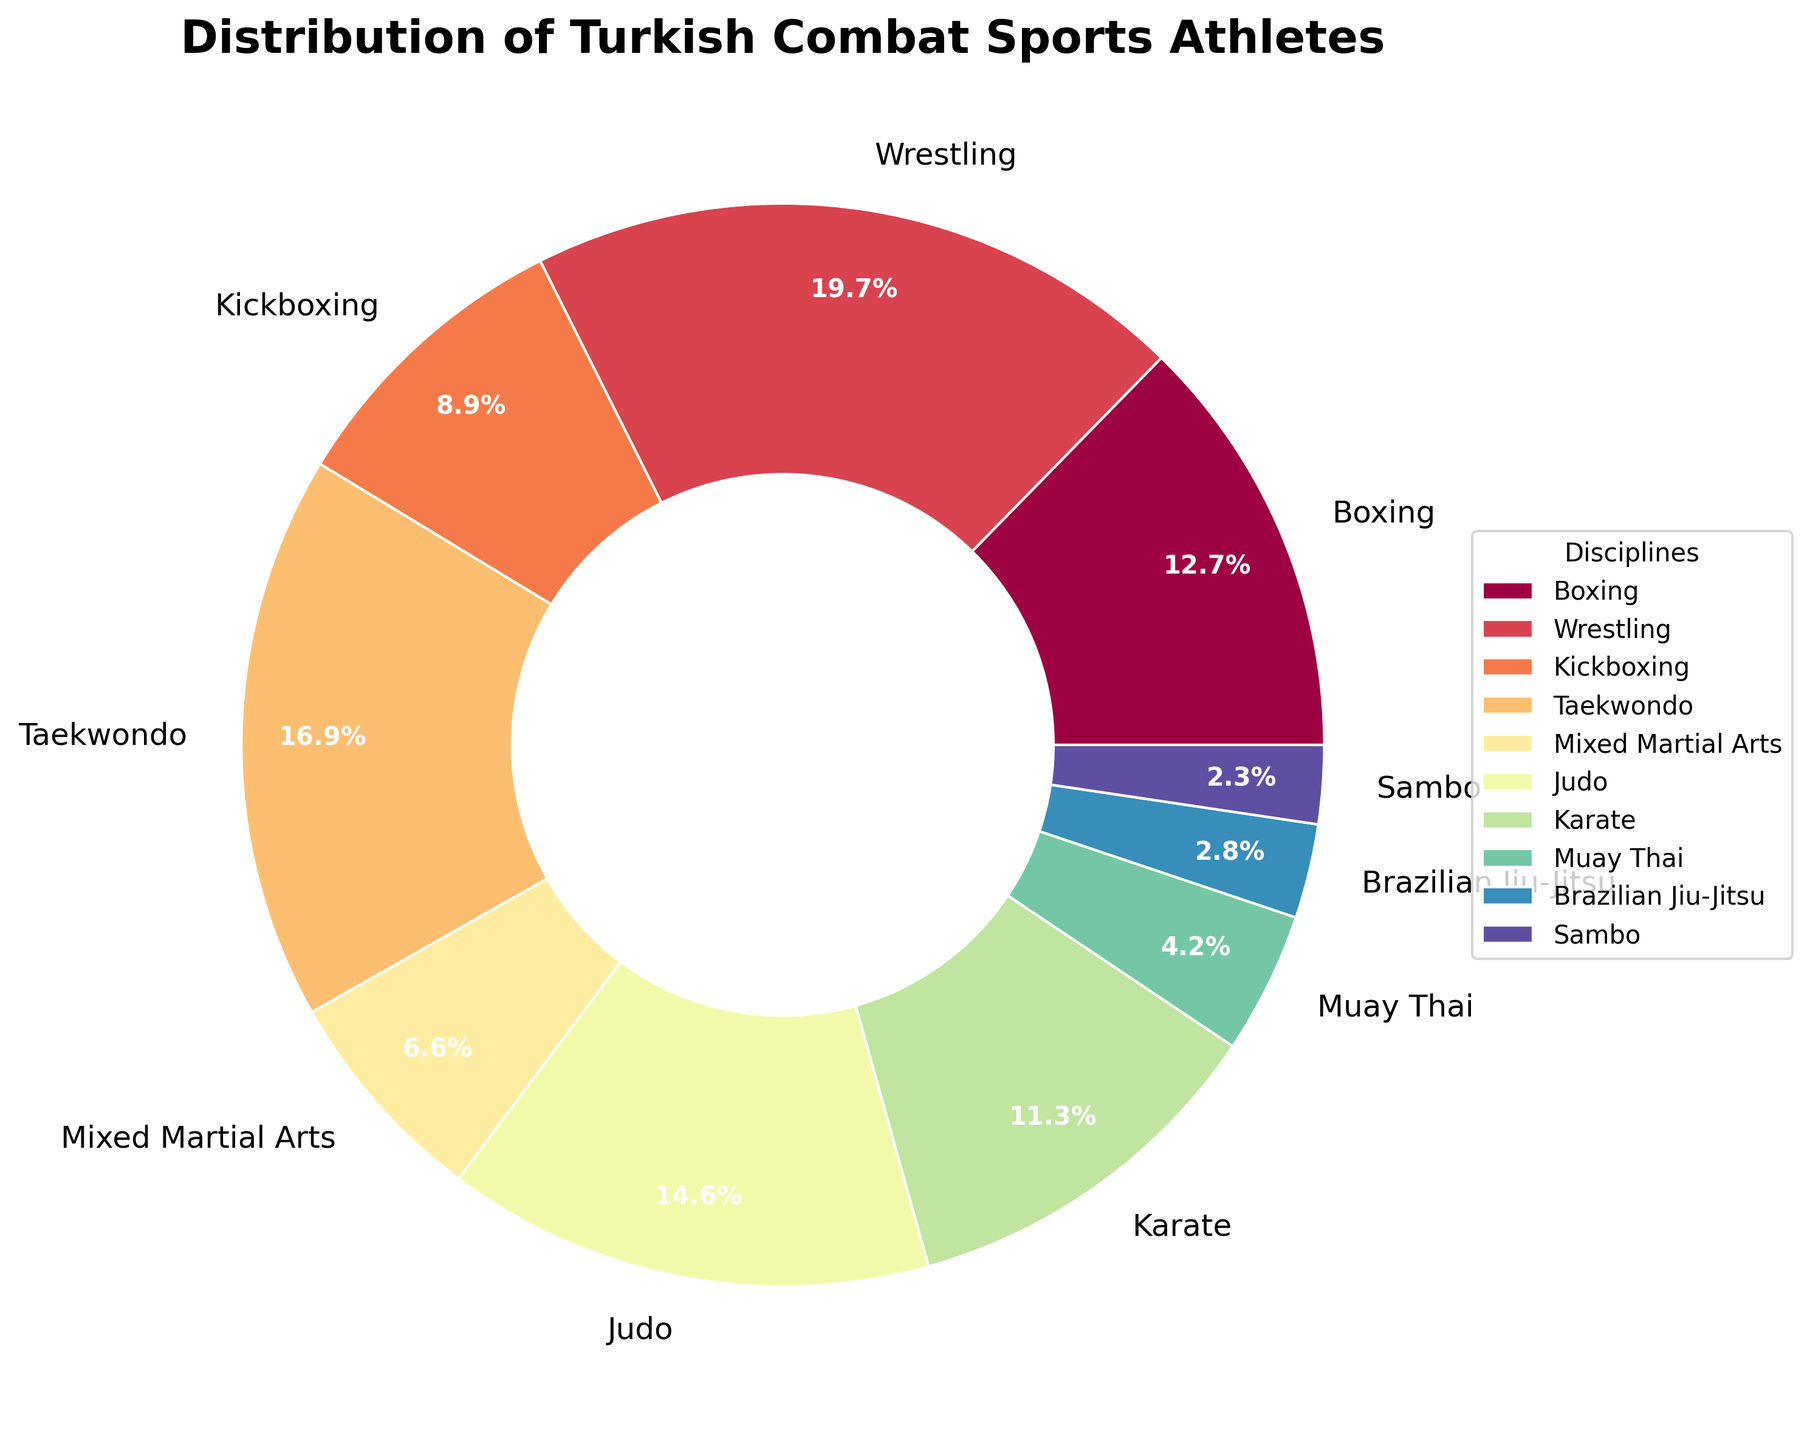Which discipline has the highest number of athletes? By looking at the pie chart, we can identify that the segment representing "Wrestling" is the largest, indicating it has the highest number of athletes.
Answer: Wrestling Which discipline has fewer athletes than Kickboxing? From the pie chart, we can see that the segments for "Muay Thai," "Brazilian Jiu-Jitsu," and "Sambo" are smaller compared to "Kickboxing," meaning they have fewer athletes.
Answer: Muay Thai, Brazilian Jiu-Jitsu, Sambo What is the combined percentage of athletes in Judo and Boxing? The pie chart shows the percentage distribution for each discipline. By summing the percentages for "Judo" and "Boxing," we get the combined value. (Judo: 13.4%, Boxing: 11.6%, so 13.4% + 11.6% = 25.0%)
Answer: 25.0% Which disciplines have a near-equal distribution of athletes and what are their percentages? Observing the pie chart, the segments for "Judo" and "Taekwondo" appear nearly equal. We can refer to their percentages for the exact values (Judo: 13.4%, Taekwondo: 15.6%).
Answer: Judo (13.4%), Taekwondo (15.6%) Which discipline has the smallest proportion of athletes and what is its percentage? The smallest segment in the pie chart represents "Sambo," indicating it has the smallest proportion of athletes. The percentage is shown directly on the pie slice.
Answer: Sambo, 2.2% How many more athletes are in Boxing compared to Brazilian Jiu-Jitsu? Comparing the athlete numbers directly, we find that boxing has 135 athletes and Brazilian Jiu-Jitsu has 30 athletes. The difference is calculated as 135 - 30.
Answer: 105 If you combine the athletes from Kickboxing, Muay Thai, and Brazilian Jiu-Jitsu, how many athletes do you get in total? By adding the number of athletes from "Kickboxing" (95), "Muay Thai" (45), and "Brazilian Jiu-Jitsu" (30), we get the total: 95 + 45 + 30 = 170.
Answer: 170 Which two disciplines have almost the same number of athletes? By searching the data in the pie chart, we find that "Karate" has 120 athletes and "Boxing" has 135 athletes, forming nearly equal proportions.
Answer: Boxing, Karate 